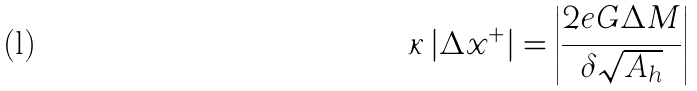<formula> <loc_0><loc_0><loc_500><loc_500>\kappa \left | \Delta x ^ { + } \right | = \left | \frac { 2 e G \Delta M } { \delta \sqrt { A _ { h } } } \right |</formula> 